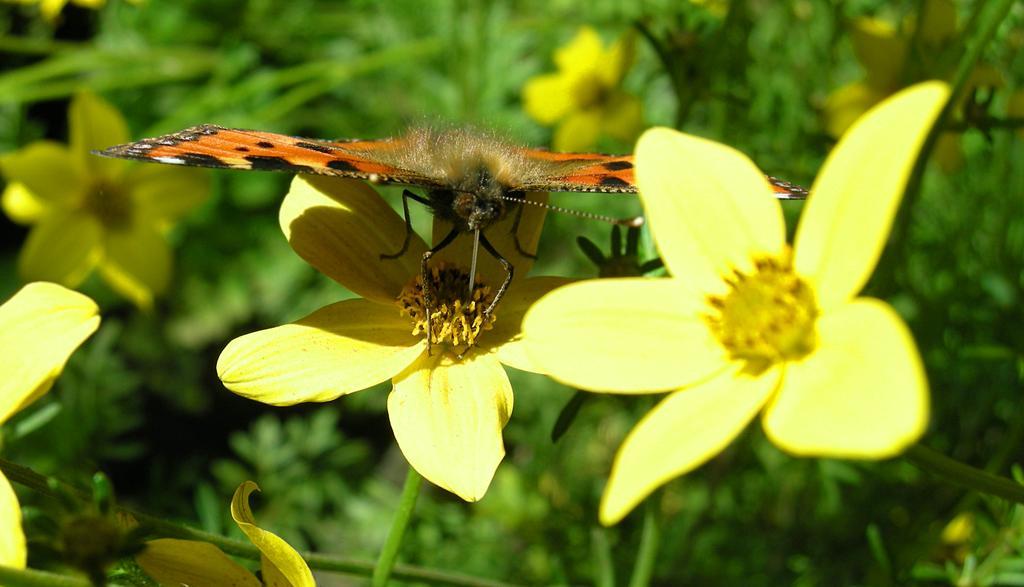Can you describe this image briefly? In this picture we can see a butterfly, flowers and in the background we can see plants. 